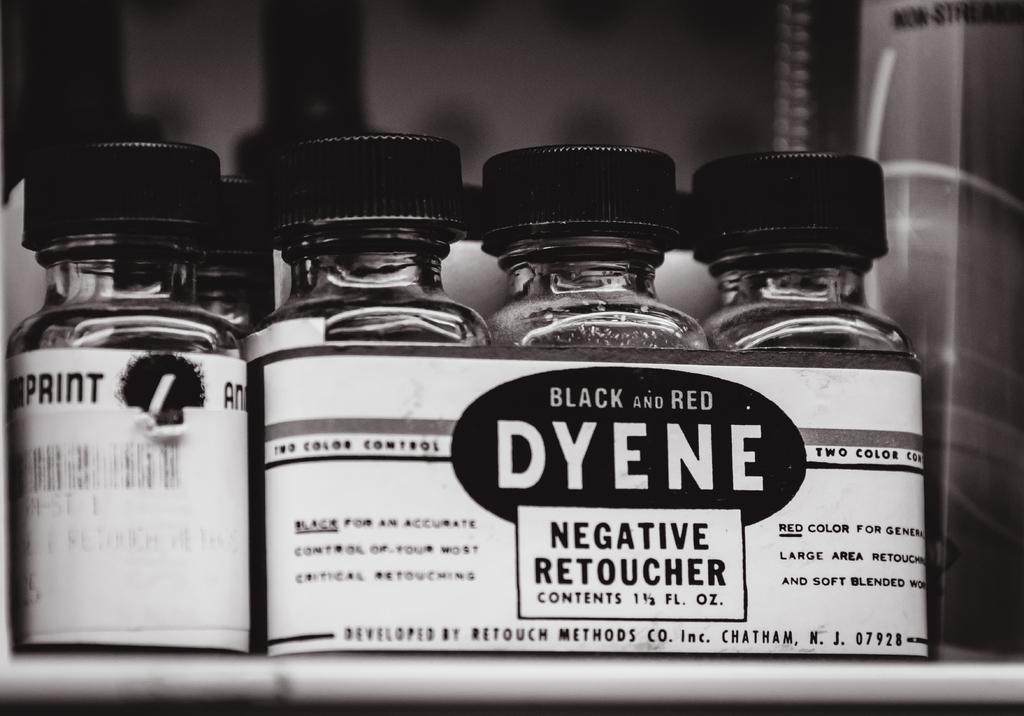<image>
Offer a succinct explanation of the picture presented. 5 bottles of chemical and 3 of them are negative retoucher. 